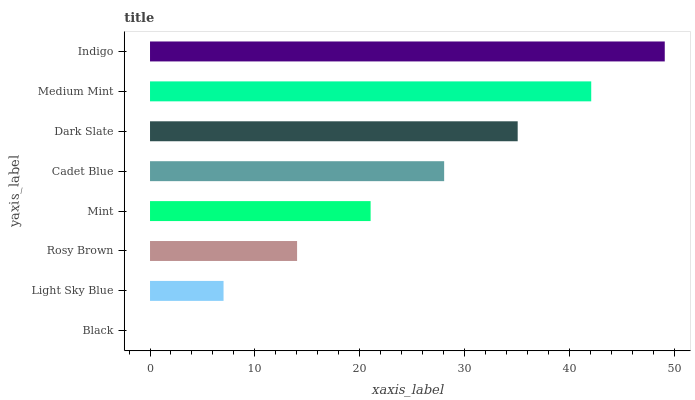Is Black the minimum?
Answer yes or no. Yes. Is Indigo the maximum?
Answer yes or no. Yes. Is Light Sky Blue the minimum?
Answer yes or no. No. Is Light Sky Blue the maximum?
Answer yes or no. No. Is Light Sky Blue greater than Black?
Answer yes or no. Yes. Is Black less than Light Sky Blue?
Answer yes or no. Yes. Is Black greater than Light Sky Blue?
Answer yes or no. No. Is Light Sky Blue less than Black?
Answer yes or no. No. Is Cadet Blue the high median?
Answer yes or no. Yes. Is Mint the low median?
Answer yes or no. Yes. Is Light Sky Blue the high median?
Answer yes or no. No. Is Rosy Brown the low median?
Answer yes or no. No. 